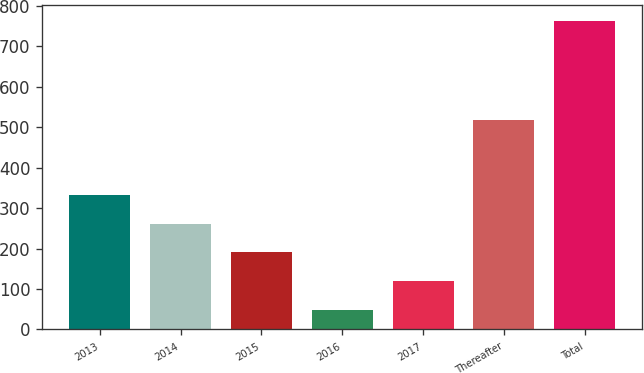Convert chart. <chart><loc_0><loc_0><loc_500><loc_500><bar_chart><fcel>2013<fcel>2014<fcel>2015<fcel>2016<fcel>2017<fcel>Thereafter<fcel>Total<nl><fcel>333.4<fcel>261.8<fcel>190.2<fcel>47<fcel>118.6<fcel>517<fcel>763<nl></chart> 